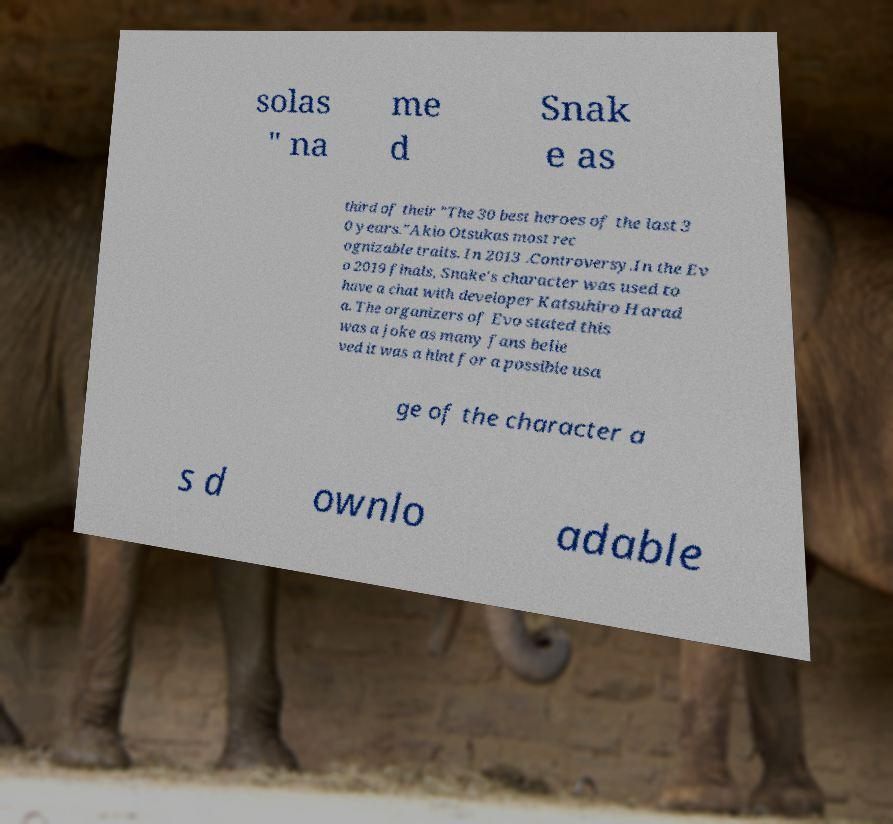Could you assist in decoding the text presented in this image and type it out clearly? solas " na me d Snak e as third of their "The 30 best heroes of the last 3 0 years."Akio Otsukas most rec ognizable traits. In 2013 .Controversy.In the Ev o 2019 finals, Snake's character was used to have a chat with developer Katsuhiro Harad a. The organizers of Evo stated this was a joke as many fans belie ved it was a hint for a possible usa ge of the character a s d ownlo adable 